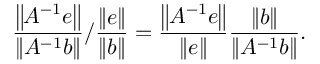Convert formula to latex. <formula><loc_0><loc_0><loc_500><loc_500>{ \frac { \left \| A ^ { - 1 } e \right \| } { \left \| A ^ { - 1 } b \right \| } } / { \frac { \| e \| } { \| b \| } } = { \frac { \left \| A ^ { - 1 } e \right \| } { \| e \| } } { \frac { \| b \| } { \left \| A ^ { - 1 } b \right \| } } .</formula> 